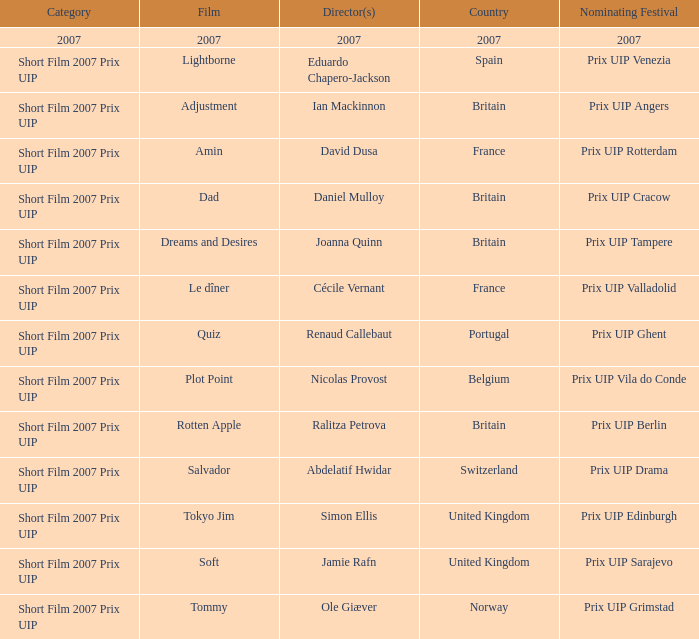What film did ian mackinnon direct that was in the short film 2007 prix uip category? Adjustment. 